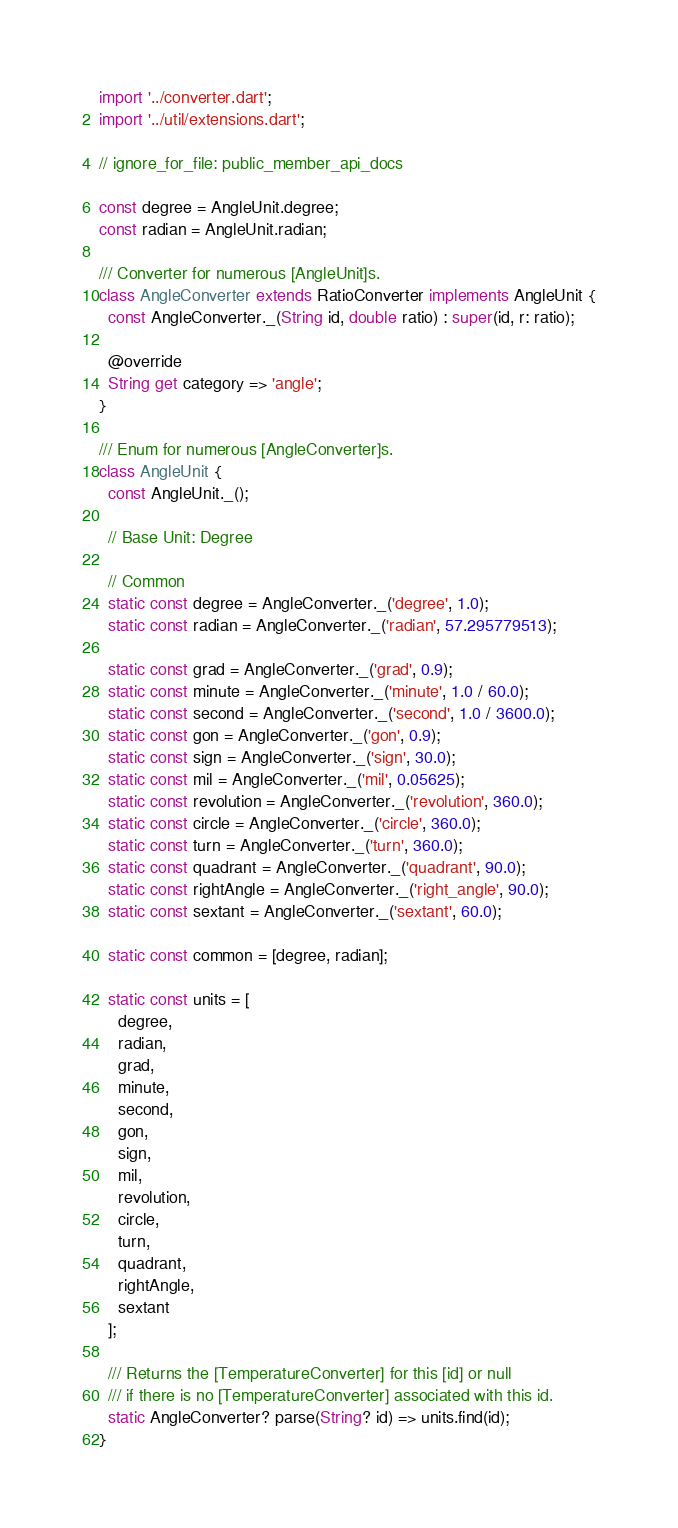<code> <loc_0><loc_0><loc_500><loc_500><_Dart_>import '../converter.dart';
import '../util/extensions.dart';

// ignore_for_file: public_member_api_docs

const degree = AngleUnit.degree;
const radian = AngleUnit.radian;

/// Converter for numerous [AngleUnit]s.
class AngleConverter extends RatioConverter implements AngleUnit {
  const AngleConverter._(String id, double ratio) : super(id, r: ratio);

  @override
  String get category => 'angle';
}

/// Enum for numerous [AngleConverter]s.
class AngleUnit {
  const AngleUnit._();

  // Base Unit: Degree

  // Common
  static const degree = AngleConverter._('degree', 1.0);
  static const radian = AngleConverter._('radian', 57.295779513);

  static const grad = AngleConverter._('grad', 0.9);
  static const minute = AngleConverter._('minute', 1.0 / 60.0);
  static const second = AngleConverter._('second', 1.0 / 3600.0);
  static const gon = AngleConverter._('gon', 0.9);
  static const sign = AngleConverter._('sign', 30.0);
  static const mil = AngleConverter._('mil', 0.05625);
  static const revolution = AngleConverter._('revolution', 360.0);
  static const circle = AngleConverter._('circle', 360.0);
  static const turn = AngleConverter._('turn', 360.0);
  static const quadrant = AngleConverter._('quadrant', 90.0);
  static const rightAngle = AngleConverter._('right_angle', 90.0);
  static const sextant = AngleConverter._('sextant', 60.0);

  static const common = [degree, radian];

  static const units = [
    degree,
    radian,
    grad,
    minute,
    second,
    gon,
    sign,
    mil,
    revolution,
    circle,
    turn,
    quadrant,
    rightAngle,
    sextant
  ];

  /// Returns the [TemperatureConverter] for this [id] or null
  /// if there is no [TemperatureConverter] associated with this id.
  static AngleConverter? parse(String? id) => units.find(id);
}
</code> 